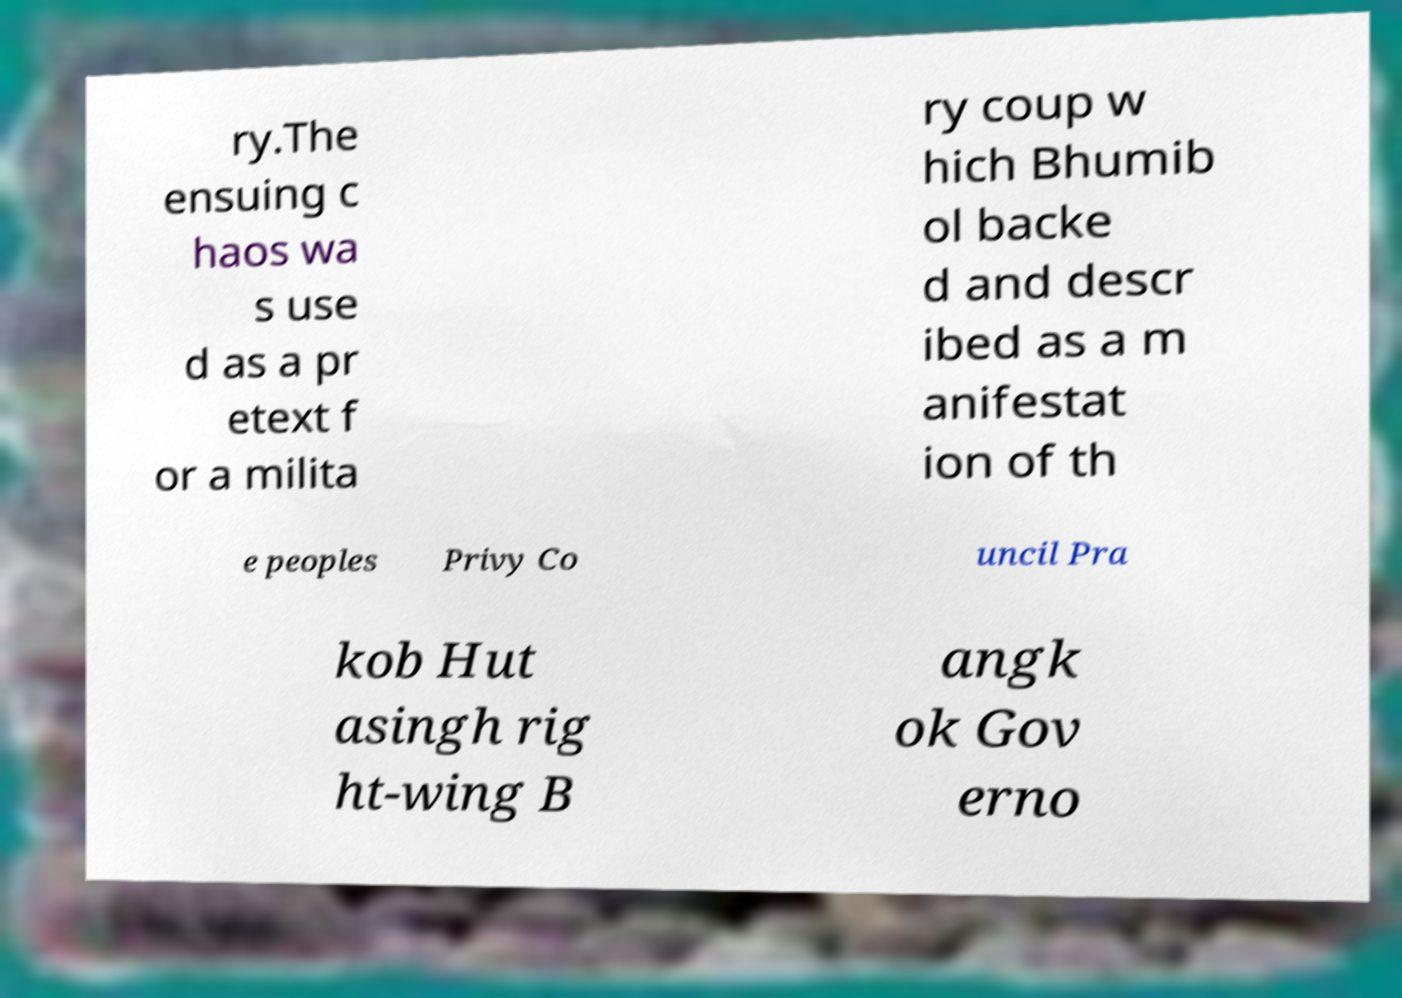I need the written content from this picture converted into text. Can you do that? ry.The ensuing c haos wa s use d as a pr etext f or a milita ry coup w hich Bhumib ol backe d and descr ibed as a m anifestat ion of th e peoples Privy Co uncil Pra kob Hut asingh rig ht-wing B angk ok Gov erno 